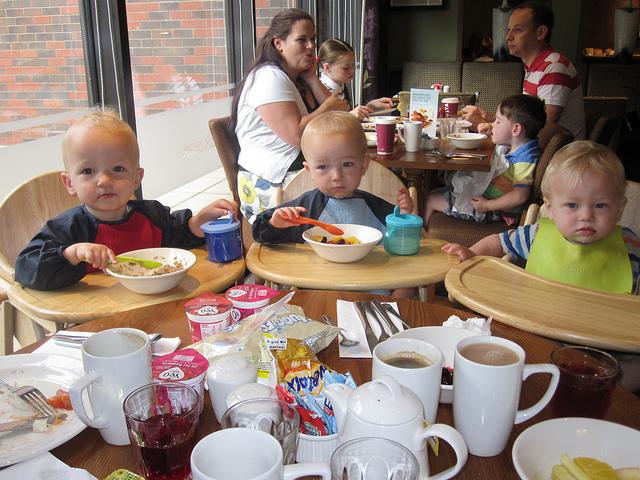Can the kids get out of their chairs?
Concise answer only. No. Are these kids happy?
Keep it brief. No. Who is the boy in red looking at?
Give a very brief answer. Camera. How many kids are there?
Keep it brief. 5. What color are the chairs?
Answer briefly. Brown. 